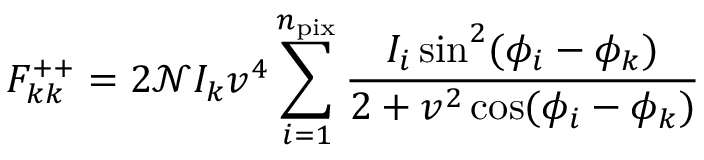Convert formula to latex. <formula><loc_0><loc_0><loc_500><loc_500>F _ { k k } ^ { + + } = 2 \mathcal { N } I _ { k } v ^ { 4 } \sum _ { i = 1 } ^ { n _ { p i x } } \frac { I _ { i } \sin ^ { 2 } ( \phi _ { i } - \phi _ { k } ) } { 2 + v ^ { 2 } \cos ( \phi _ { i } - \phi _ { k } ) }</formula> 